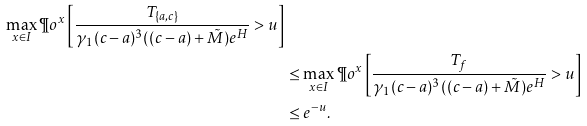Convert formula to latex. <formula><loc_0><loc_0><loc_500><loc_500>{ \max _ { x \in I } \P o ^ { x } \left [ \frac { T _ { \{ a , c \} } } { { \gamma } _ { 1 } ( c - a ) ^ { 3 } ( ( c - a ) + { \tilde { M } } ) e ^ { H } } > u \right ] } \\ & \leq \max _ { x \in I } \P o ^ { x } \left [ \frac { T _ { f } } { { \gamma } _ { 1 } ( c - a ) ^ { 3 } ( ( c - a ) + { \tilde { M } } ) e ^ { H } } > u \right ] \\ & \leq e ^ { - u } .</formula> 